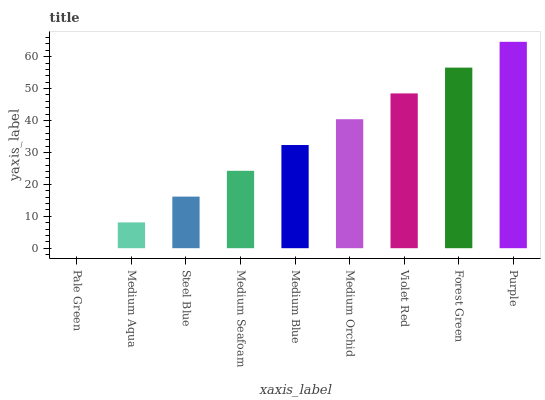Is Pale Green the minimum?
Answer yes or no. Yes. Is Purple the maximum?
Answer yes or no. Yes. Is Medium Aqua the minimum?
Answer yes or no. No. Is Medium Aqua the maximum?
Answer yes or no. No. Is Medium Aqua greater than Pale Green?
Answer yes or no. Yes. Is Pale Green less than Medium Aqua?
Answer yes or no. Yes. Is Pale Green greater than Medium Aqua?
Answer yes or no. No. Is Medium Aqua less than Pale Green?
Answer yes or no. No. Is Medium Blue the high median?
Answer yes or no. Yes. Is Medium Blue the low median?
Answer yes or no. Yes. Is Steel Blue the high median?
Answer yes or no. No. Is Medium Aqua the low median?
Answer yes or no. No. 